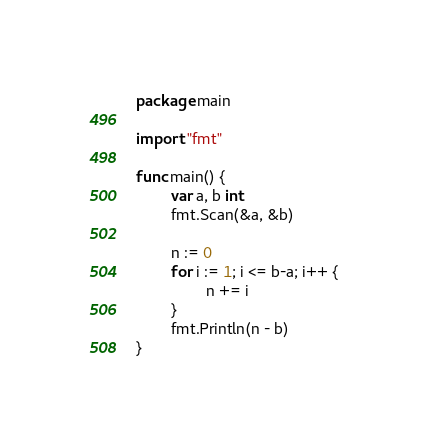<code> <loc_0><loc_0><loc_500><loc_500><_Go_>package main

import "fmt"

func main() {
        var a, b int
        fmt.Scan(&a, &b)

        n := 0
        for i := 1; i <= b-a; i++ {
                n += i
        }
        fmt.Println(n - b)
}</code> 